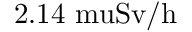Convert formula to latex. <formula><loc_0><loc_0><loc_500><loc_500>2 . 1 4 { \ m u } S v / h</formula> 